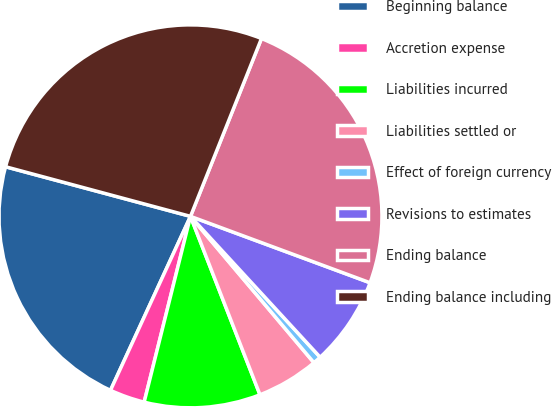Convert chart to OTSL. <chart><loc_0><loc_0><loc_500><loc_500><pie_chart><fcel>Beginning balance<fcel>Accretion expense<fcel>Liabilities incurred<fcel>Liabilities settled or<fcel>Effect of foreign currency<fcel>Revisions to estimates<fcel>Ending balance<fcel>Ending balance including<nl><fcel>22.31%<fcel>2.97%<fcel>9.8%<fcel>5.24%<fcel>0.69%<fcel>7.52%<fcel>24.59%<fcel>26.87%<nl></chart> 